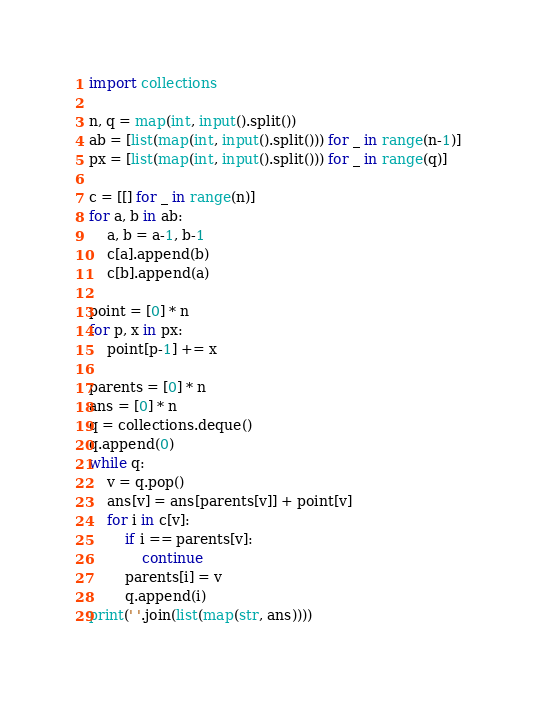Convert code to text. <code><loc_0><loc_0><loc_500><loc_500><_Python_>import collections

n, q = map(int, input().split())
ab = [list(map(int, input().split())) for _ in range(n-1)]
px = [list(map(int, input().split())) for _ in range(q)]

c = [[] for _ in range(n)]
for a, b in ab:
    a, b = a-1, b-1
    c[a].append(b)
    c[b].append(a)

point = [0] * n
for p, x in px:
    point[p-1] += x

parents = [0] * n
ans = [0] * n
q = collections.deque()
q.append(0)
while q:
    v = q.pop()
    ans[v] = ans[parents[v]] + point[v]
    for i in c[v]:
        if i == parents[v]:
            continue
        parents[i] = v
        q.append(i)
print(' '.join(list(map(str, ans))))</code> 